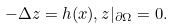<formula> <loc_0><loc_0><loc_500><loc_500>- \Delta z = h ( x ) , z | _ { \partial \Omega } = 0 .</formula> 